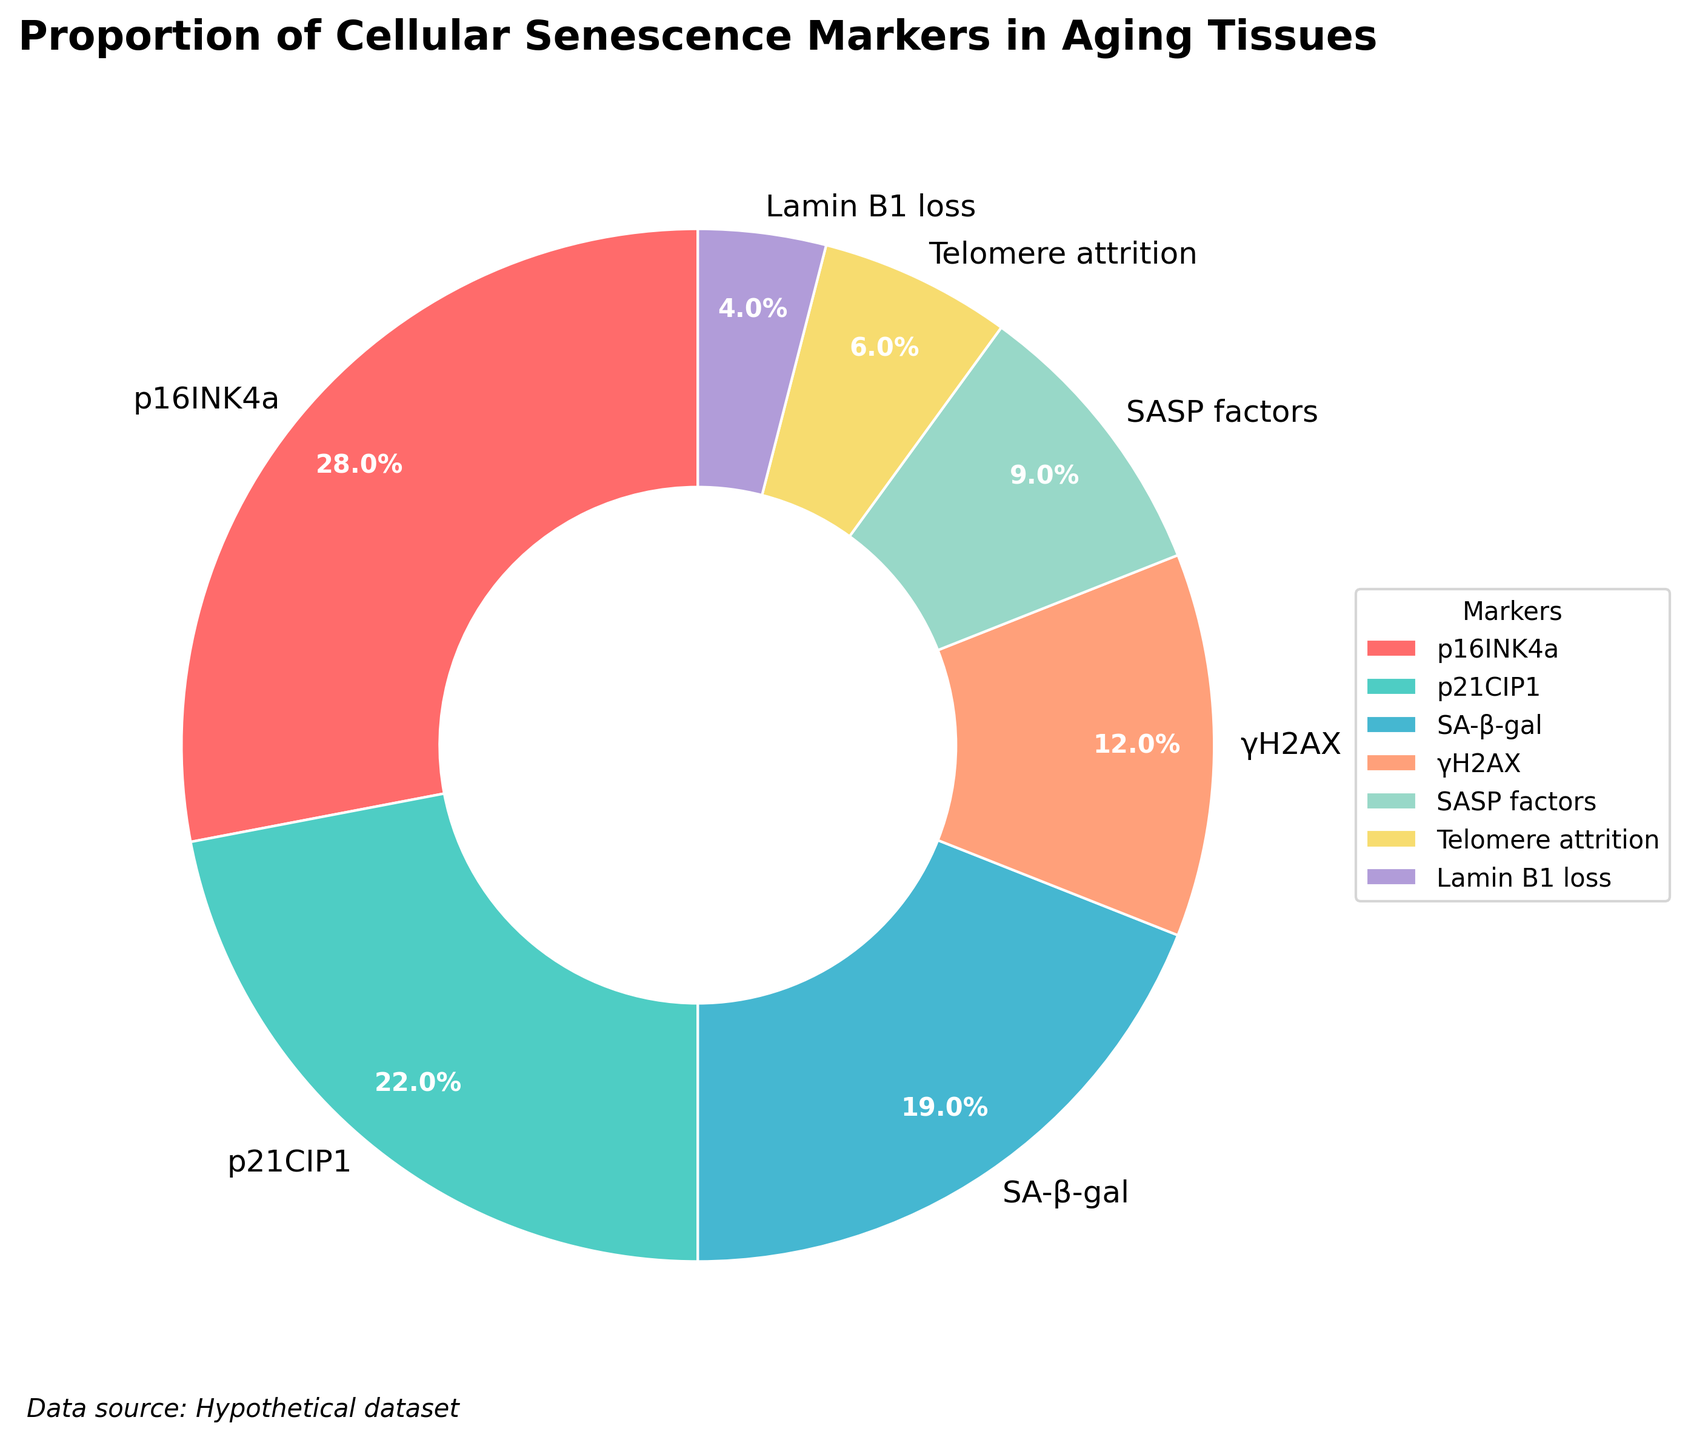Which cellular senescence marker has the highest proportion in aging tissues? The marker with the highest proportion can be identified as the one with the largest percentage in the pie chart. p16INK4a has the highest proportion of 28%.
Answer: p16INK4a What is the combined percentage of p16INK4a and p21CIP1? To find the combined percentage, add the values of p16INK4a (28%) and p21CIP1 (22%). 28% + 22% = 50%.
Answer: 50% Which marker has a smaller proportion, γH2AX or Telomere attrition? A comparison of the percentages for γH2AX (12%) and Telomere attrition (6%) shows that Telomere attrition is smaller.
Answer: Telomere attrition What is the percentage difference between SA-β-gal and Lamin B1 loss? Subtract the percentage of Lamin B1 loss (4%) from the percentage of SA-β-gal (19%). 19% - 4% = 15%.
Answer: 15% What is the visual feature of the markers with the smallest proportion? The marker with the smallest proportion, Lamin B1 loss (4%), is depicted with the smallest wedge in the pie chart.
Answer: smallest wedge How many markers have a proportion of 10% or more? A visual scan of the pie chart for markers with percentages of 10% or more reveals four markers: p16INK4a (28%), p21CIP1 (22%), SA-β-gal (19%), and γH2AX (12%).
Answer: 4 What is the combined percentage of all markers with a proportion less than 10%? Sum the percentages of SASP factors (9%), Telomere attrition (6%), and Lamin B1 loss (4%). 9% + 6% + 4% = 19%.
Answer: 19% Which marker is represented in green? The pie chart indicates that p21CIP1 is represented in green color.
Answer: p21CIP1 What is the percentage range of the markers in the pie chart? The range is calculated by subtracting the smallest percentage (Lamin B1 loss, 4%) from the largest percentage (p16INK4a, 28%). 28% - 4% = 24%.
Answer: 24% Which marker has a proportion closest to the average proportion of all markers? First, calculate the average proportion: (28% + 22% + 19% + 12% + 9% + 6% + 4%)/7 = 100%/7 ≈ 14.3%. The closest proportion is γH2AX at 12%.
Answer: γH2AX 